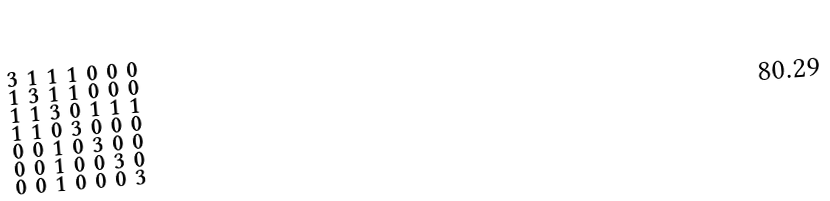<formula> <loc_0><loc_0><loc_500><loc_500>\begin{smallmatrix} 3 & 1 & 1 & 1 & 0 & 0 & 0 \\ 1 & 3 & 1 & 1 & 0 & 0 & 0 \\ 1 & 1 & 3 & 0 & 1 & 1 & 1 \\ 1 & 1 & 0 & 3 & 0 & 0 & 0 \\ 0 & 0 & 1 & 0 & 3 & 0 & 0 \\ 0 & 0 & 1 & 0 & 0 & 3 & 0 \\ 0 & 0 & 1 & 0 & 0 & 0 & 3 \end{smallmatrix}</formula> 